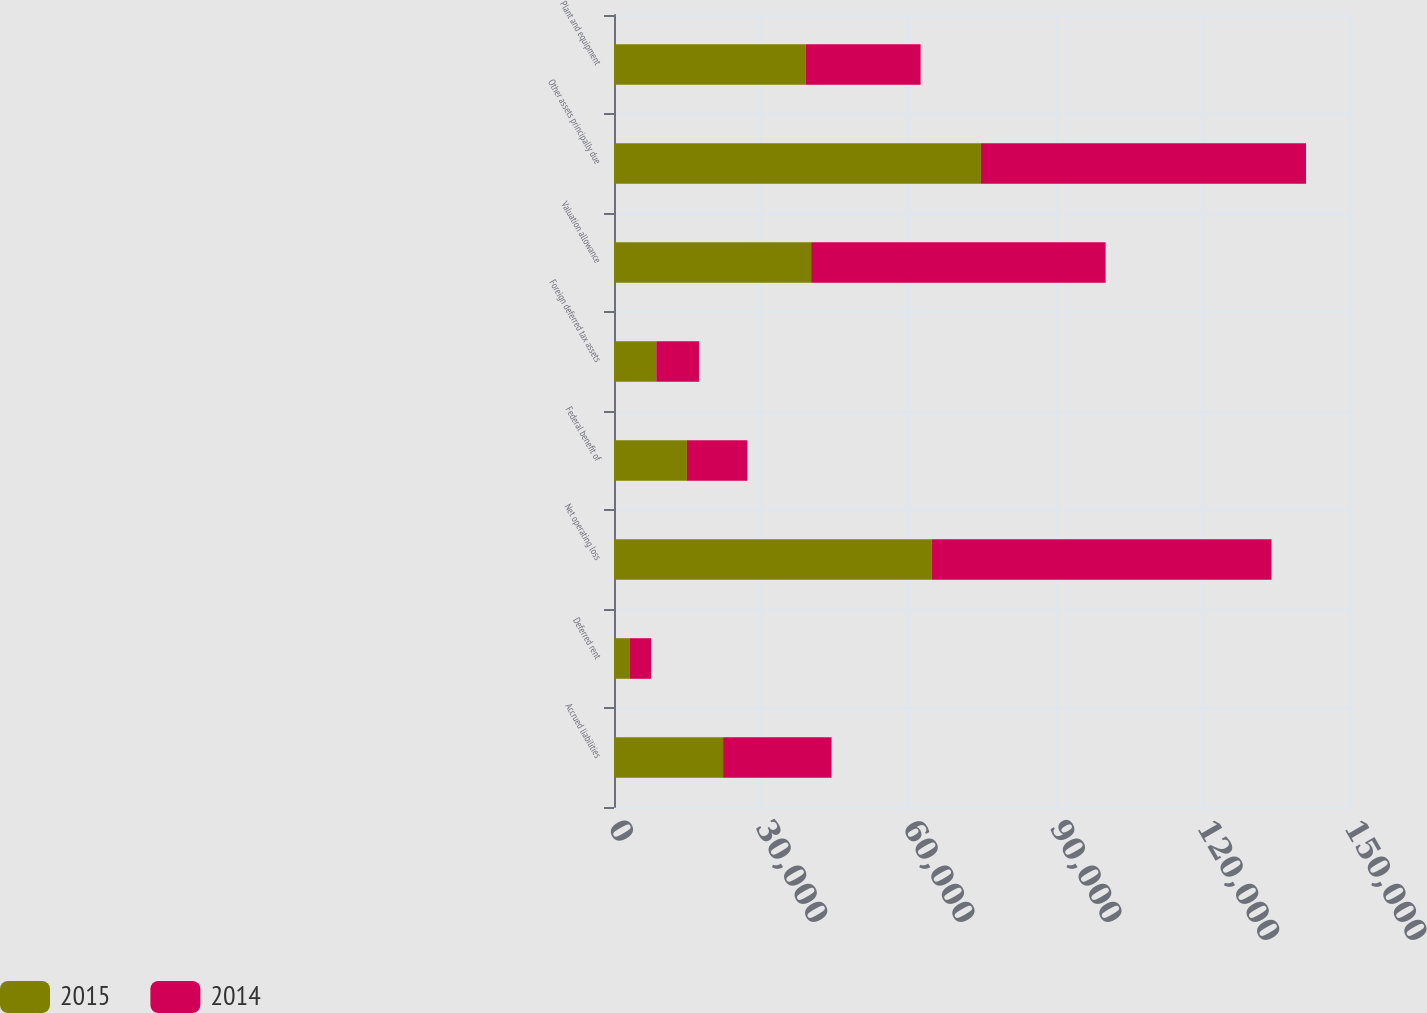Convert chart. <chart><loc_0><loc_0><loc_500><loc_500><stacked_bar_chart><ecel><fcel>Accrued liabilities<fcel>Deferred rent<fcel>Net operating loss<fcel>Federal benefit of<fcel>Foreign deferred tax assets<fcel>Valuation allowance<fcel>Other assets principally due<fcel>Plant and equipment<nl><fcel>2015<fcel>22236<fcel>3144<fcel>64718<fcel>14859<fcel>8620<fcel>40182<fcel>74782<fcel>39079<nl><fcel>2014<fcel>22107<fcel>4426<fcel>69290<fcel>12327<fcel>8698<fcel>60009<fcel>66254<fcel>23408<nl></chart> 